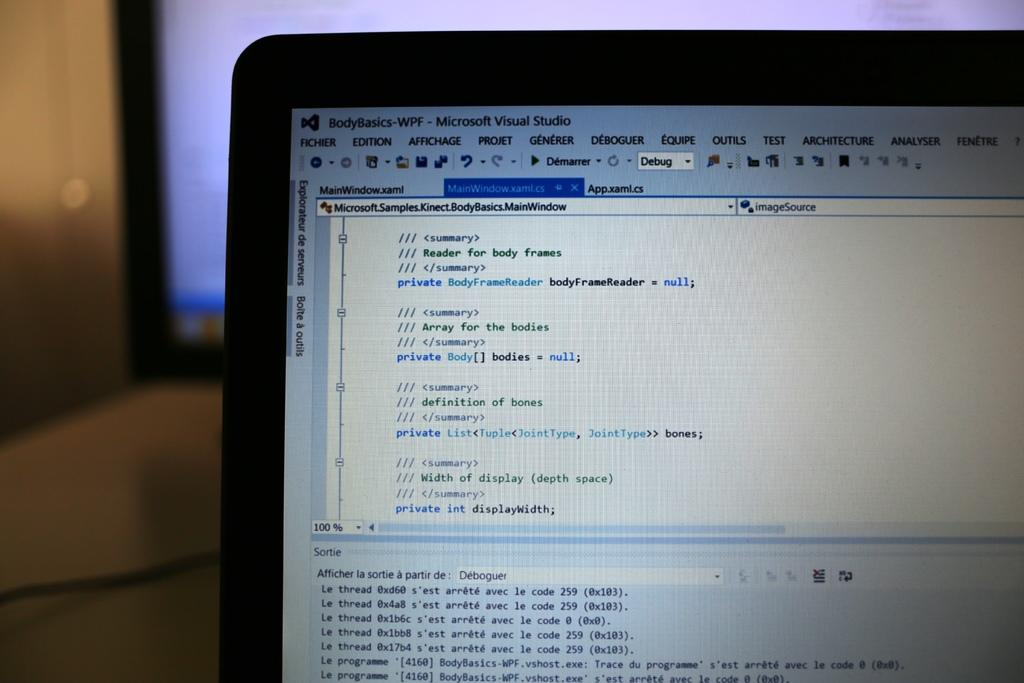<image>
Present a compact description of the photo's key features. A body basics app is open on the screen 